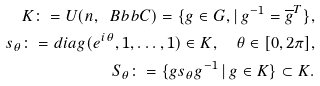Convert formula to latex. <formula><loc_0><loc_0><loc_500><loc_500>K \colon = U ( n , \ B b b C ) = \{ g \in G , | \, g ^ { - 1 } = \overline { g } ^ { T } \} , \\ s _ { \theta } \colon = d i a g ( e ^ { i \theta } , 1 , \dots , 1 ) \in K , \quad \theta \in [ 0 , 2 \pi ] , \\ S _ { \theta } \colon = \{ g s _ { \theta } g ^ { - 1 } \, | \, g \in K \} \subset K .</formula> 